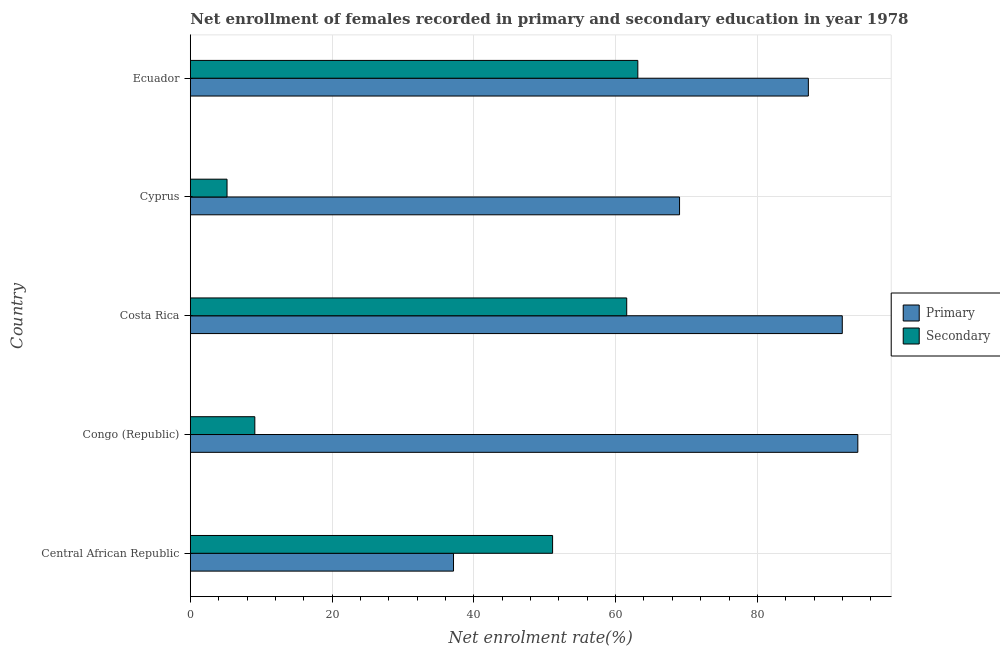How many groups of bars are there?
Give a very brief answer. 5. Are the number of bars per tick equal to the number of legend labels?
Ensure brevity in your answer.  Yes. How many bars are there on the 2nd tick from the bottom?
Ensure brevity in your answer.  2. What is the label of the 1st group of bars from the top?
Your response must be concise. Ecuador. What is the enrollment rate in primary education in Cyprus?
Ensure brevity in your answer.  69.02. Across all countries, what is the maximum enrollment rate in primary education?
Your answer should be very brief. 94.17. Across all countries, what is the minimum enrollment rate in primary education?
Offer a very short reply. 37.13. In which country was the enrollment rate in secondary education maximum?
Provide a succinct answer. Ecuador. In which country was the enrollment rate in secondary education minimum?
Make the answer very short. Cyprus. What is the total enrollment rate in secondary education in the graph?
Give a very brief answer. 190.1. What is the difference between the enrollment rate in secondary education in Central African Republic and that in Costa Rica?
Provide a succinct answer. -10.46. What is the difference between the enrollment rate in primary education in Ecuador and the enrollment rate in secondary education in Cyprus?
Offer a terse response. 82.01. What is the average enrollment rate in secondary education per country?
Your response must be concise. 38.02. What is the difference between the enrollment rate in primary education and enrollment rate in secondary education in Central African Republic?
Offer a very short reply. -13.98. In how many countries, is the enrollment rate in secondary education greater than 24 %?
Ensure brevity in your answer.  3. What is the ratio of the enrollment rate in secondary education in Congo (Republic) to that in Costa Rica?
Give a very brief answer. 0.15. Is the enrollment rate in primary education in Central African Republic less than that in Ecuador?
Provide a short and direct response. Yes. What is the difference between the highest and the second highest enrollment rate in primary education?
Your response must be concise. 2.19. What is the difference between the highest and the lowest enrollment rate in primary education?
Keep it short and to the point. 57.04. What does the 1st bar from the top in Congo (Republic) represents?
Ensure brevity in your answer.  Secondary. What does the 1st bar from the bottom in Ecuador represents?
Provide a succinct answer. Primary. How many bars are there?
Your answer should be very brief. 10. Are all the bars in the graph horizontal?
Offer a terse response. Yes. How many countries are there in the graph?
Keep it short and to the point. 5. Where does the legend appear in the graph?
Provide a succinct answer. Center right. How many legend labels are there?
Ensure brevity in your answer.  2. How are the legend labels stacked?
Keep it short and to the point. Vertical. What is the title of the graph?
Ensure brevity in your answer.  Net enrollment of females recorded in primary and secondary education in year 1978. What is the label or title of the X-axis?
Keep it short and to the point. Net enrolment rate(%). What is the label or title of the Y-axis?
Offer a terse response. Country. What is the Net enrolment rate(%) in Primary in Central African Republic?
Provide a succinct answer. 37.13. What is the Net enrolment rate(%) of Secondary in Central African Republic?
Make the answer very short. 51.11. What is the Net enrolment rate(%) of Primary in Congo (Republic)?
Give a very brief answer. 94.17. What is the Net enrolment rate(%) in Secondary in Congo (Republic)?
Offer a terse response. 9.1. What is the Net enrolment rate(%) in Primary in Costa Rica?
Provide a succinct answer. 91.98. What is the Net enrolment rate(%) of Secondary in Costa Rica?
Offer a terse response. 61.57. What is the Net enrolment rate(%) of Primary in Cyprus?
Give a very brief answer. 69.02. What is the Net enrolment rate(%) of Secondary in Cyprus?
Offer a very short reply. 5.18. What is the Net enrolment rate(%) of Primary in Ecuador?
Provide a succinct answer. 87.19. What is the Net enrolment rate(%) of Secondary in Ecuador?
Your answer should be very brief. 63.13. Across all countries, what is the maximum Net enrolment rate(%) in Primary?
Your answer should be compact. 94.17. Across all countries, what is the maximum Net enrolment rate(%) of Secondary?
Offer a very short reply. 63.13. Across all countries, what is the minimum Net enrolment rate(%) in Primary?
Ensure brevity in your answer.  37.13. Across all countries, what is the minimum Net enrolment rate(%) in Secondary?
Your answer should be compact. 5.18. What is the total Net enrolment rate(%) of Primary in the graph?
Ensure brevity in your answer.  379.49. What is the total Net enrolment rate(%) of Secondary in the graph?
Your response must be concise. 190.1. What is the difference between the Net enrolment rate(%) of Primary in Central African Republic and that in Congo (Republic)?
Provide a succinct answer. -57.04. What is the difference between the Net enrolment rate(%) in Secondary in Central African Republic and that in Congo (Republic)?
Provide a short and direct response. 42. What is the difference between the Net enrolment rate(%) in Primary in Central African Republic and that in Costa Rica?
Your answer should be compact. -54.84. What is the difference between the Net enrolment rate(%) of Secondary in Central African Republic and that in Costa Rica?
Give a very brief answer. -10.46. What is the difference between the Net enrolment rate(%) of Primary in Central African Republic and that in Cyprus?
Your answer should be compact. -31.89. What is the difference between the Net enrolment rate(%) in Secondary in Central African Republic and that in Cyprus?
Keep it short and to the point. 45.93. What is the difference between the Net enrolment rate(%) in Primary in Central African Republic and that in Ecuador?
Offer a terse response. -50.06. What is the difference between the Net enrolment rate(%) in Secondary in Central African Republic and that in Ecuador?
Provide a succinct answer. -12.02. What is the difference between the Net enrolment rate(%) in Primary in Congo (Republic) and that in Costa Rica?
Keep it short and to the point. 2.19. What is the difference between the Net enrolment rate(%) of Secondary in Congo (Republic) and that in Costa Rica?
Provide a short and direct response. -52.46. What is the difference between the Net enrolment rate(%) in Primary in Congo (Republic) and that in Cyprus?
Keep it short and to the point. 25.15. What is the difference between the Net enrolment rate(%) in Secondary in Congo (Republic) and that in Cyprus?
Your answer should be compact. 3.92. What is the difference between the Net enrolment rate(%) of Primary in Congo (Republic) and that in Ecuador?
Offer a terse response. 6.98. What is the difference between the Net enrolment rate(%) of Secondary in Congo (Republic) and that in Ecuador?
Offer a very short reply. -54.03. What is the difference between the Net enrolment rate(%) of Primary in Costa Rica and that in Cyprus?
Provide a succinct answer. 22.96. What is the difference between the Net enrolment rate(%) of Secondary in Costa Rica and that in Cyprus?
Provide a succinct answer. 56.38. What is the difference between the Net enrolment rate(%) of Primary in Costa Rica and that in Ecuador?
Provide a short and direct response. 4.78. What is the difference between the Net enrolment rate(%) of Secondary in Costa Rica and that in Ecuador?
Your answer should be compact. -1.57. What is the difference between the Net enrolment rate(%) in Primary in Cyprus and that in Ecuador?
Provide a short and direct response. -18.17. What is the difference between the Net enrolment rate(%) of Secondary in Cyprus and that in Ecuador?
Keep it short and to the point. -57.95. What is the difference between the Net enrolment rate(%) in Primary in Central African Republic and the Net enrolment rate(%) in Secondary in Congo (Republic)?
Offer a very short reply. 28.03. What is the difference between the Net enrolment rate(%) in Primary in Central African Republic and the Net enrolment rate(%) in Secondary in Costa Rica?
Offer a very short reply. -24.43. What is the difference between the Net enrolment rate(%) of Primary in Central African Republic and the Net enrolment rate(%) of Secondary in Cyprus?
Provide a short and direct response. 31.95. What is the difference between the Net enrolment rate(%) of Primary in Central African Republic and the Net enrolment rate(%) of Secondary in Ecuador?
Make the answer very short. -26. What is the difference between the Net enrolment rate(%) in Primary in Congo (Republic) and the Net enrolment rate(%) in Secondary in Costa Rica?
Give a very brief answer. 32.6. What is the difference between the Net enrolment rate(%) in Primary in Congo (Republic) and the Net enrolment rate(%) in Secondary in Cyprus?
Your answer should be very brief. 88.99. What is the difference between the Net enrolment rate(%) of Primary in Congo (Republic) and the Net enrolment rate(%) of Secondary in Ecuador?
Keep it short and to the point. 31.04. What is the difference between the Net enrolment rate(%) in Primary in Costa Rica and the Net enrolment rate(%) in Secondary in Cyprus?
Your answer should be compact. 86.79. What is the difference between the Net enrolment rate(%) of Primary in Costa Rica and the Net enrolment rate(%) of Secondary in Ecuador?
Provide a succinct answer. 28.84. What is the difference between the Net enrolment rate(%) in Primary in Cyprus and the Net enrolment rate(%) in Secondary in Ecuador?
Offer a terse response. 5.89. What is the average Net enrolment rate(%) of Primary per country?
Your answer should be compact. 75.9. What is the average Net enrolment rate(%) in Secondary per country?
Offer a very short reply. 38.02. What is the difference between the Net enrolment rate(%) in Primary and Net enrolment rate(%) in Secondary in Central African Republic?
Offer a terse response. -13.98. What is the difference between the Net enrolment rate(%) of Primary and Net enrolment rate(%) of Secondary in Congo (Republic)?
Offer a terse response. 85.06. What is the difference between the Net enrolment rate(%) in Primary and Net enrolment rate(%) in Secondary in Costa Rica?
Give a very brief answer. 30.41. What is the difference between the Net enrolment rate(%) of Primary and Net enrolment rate(%) of Secondary in Cyprus?
Give a very brief answer. 63.84. What is the difference between the Net enrolment rate(%) in Primary and Net enrolment rate(%) in Secondary in Ecuador?
Provide a succinct answer. 24.06. What is the ratio of the Net enrolment rate(%) in Primary in Central African Republic to that in Congo (Republic)?
Provide a succinct answer. 0.39. What is the ratio of the Net enrolment rate(%) of Secondary in Central African Republic to that in Congo (Republic)?
Ensure brevity in your answer.  5.61. What is the ratio of the Net enrolment rate(%) in Primary in Central African Republic to that in Costa Rica?
Make the answer very short. 0.4. What is the ratio of the Net enrolment rate(%) in Secondary in Central African Republic to that in Costa Rica?
Offer a very short reply. 0.83. What is the ratio of the Net enrolment rate(%) of Primary in Central African Republic to that in Cyprus?
Offer a very short reply. 0.54. What is the ratio of the Net enrolment rate(%) of Secondary in Central African Republic to that in Cyprus?
Give a very brief answer. 9.86. What is the ratio of the Net enrolment rate(%) of Primary in Central African Republic to that in Ecuador?
Ensure brevity in your answer.  0.43. What is the ratio of the Net enrolment rate(%) of Secondary in Central African Republic to that in Ecuador?
Keep it short and to the point. 0.81. What is the ratio of the Net enrolment rate(%) of Primary in Congo (Republic) to that in Costa Rica?
Make the answer very short. 1.02. What is the ratio of the Net enrolment rate(%) of Secondary in Congo (Republic) to that in Costa Rica?
Provide a short and direct response. 0.15. What is the ratio of the Net enrolment rate(%) in Primary in Congo (Republic) to that in Cyprus?
Your response must be concise. 1.36. What is the ratio of the Net enrolment rate(%) in Secondary in Congo (Republic) to that in Cyprus?
Provide a short and direct response. 1.76. What is the ratio of the Net enrolment rate(%) in Primary in Congo (Republic) to that in Ecuador?
Offer a very short reply. 1.08. What is the ratio of the Net enrolment rate(%) in Secondary in Congo (Republic) to that in Ecuador?
Your answer should be compact. 0.14. What is the ratio of the Net enrolment rate(%) of Primary in Costa Rica to that in Cyprus?
Keep it short and to the point. 1.33. What is the ratio of the Net enrolment rate(%) of Secondary in Costa Rica to that in Cyprus?
Make the answer very short. 11.88. What is the ratio of the Net enrolment rate(%) in Primary in Costa Rica to that in Ecuador?
Your response must be concise. 1.05. What is the ratio of the Net enrolment rate(%) of Secondary in Costa Rica to that in Ecuador?
Provide a short and direct response. 0.98. What is the ratio of the Net enrolment rate(%) in Primary in Cyprus to that in Ecuador?
Make the answer very short. 0.79. What is the ratio of the Net enrolment rate(%) of Secondary in Cyprus to that in Ecuador?
Give a very brief answer. 0.08. What is the difference between the highest and the second highest Net enrolment rate(%) in Primary?
Your response must be concise. 2.19. What is the difference between the highest and the second highest Net enrolment rate(%) in Secondary?
Provide a succinct answer. 1.57. What is the difference between the highest and the lowest Net enrolment rate(%) of Primary?
Keep it short and to the point. 57.04. What is the difference between the highest and the lowest Net enrolment rate(%) of Secondary?
Your answer should be compact. 57.95. 